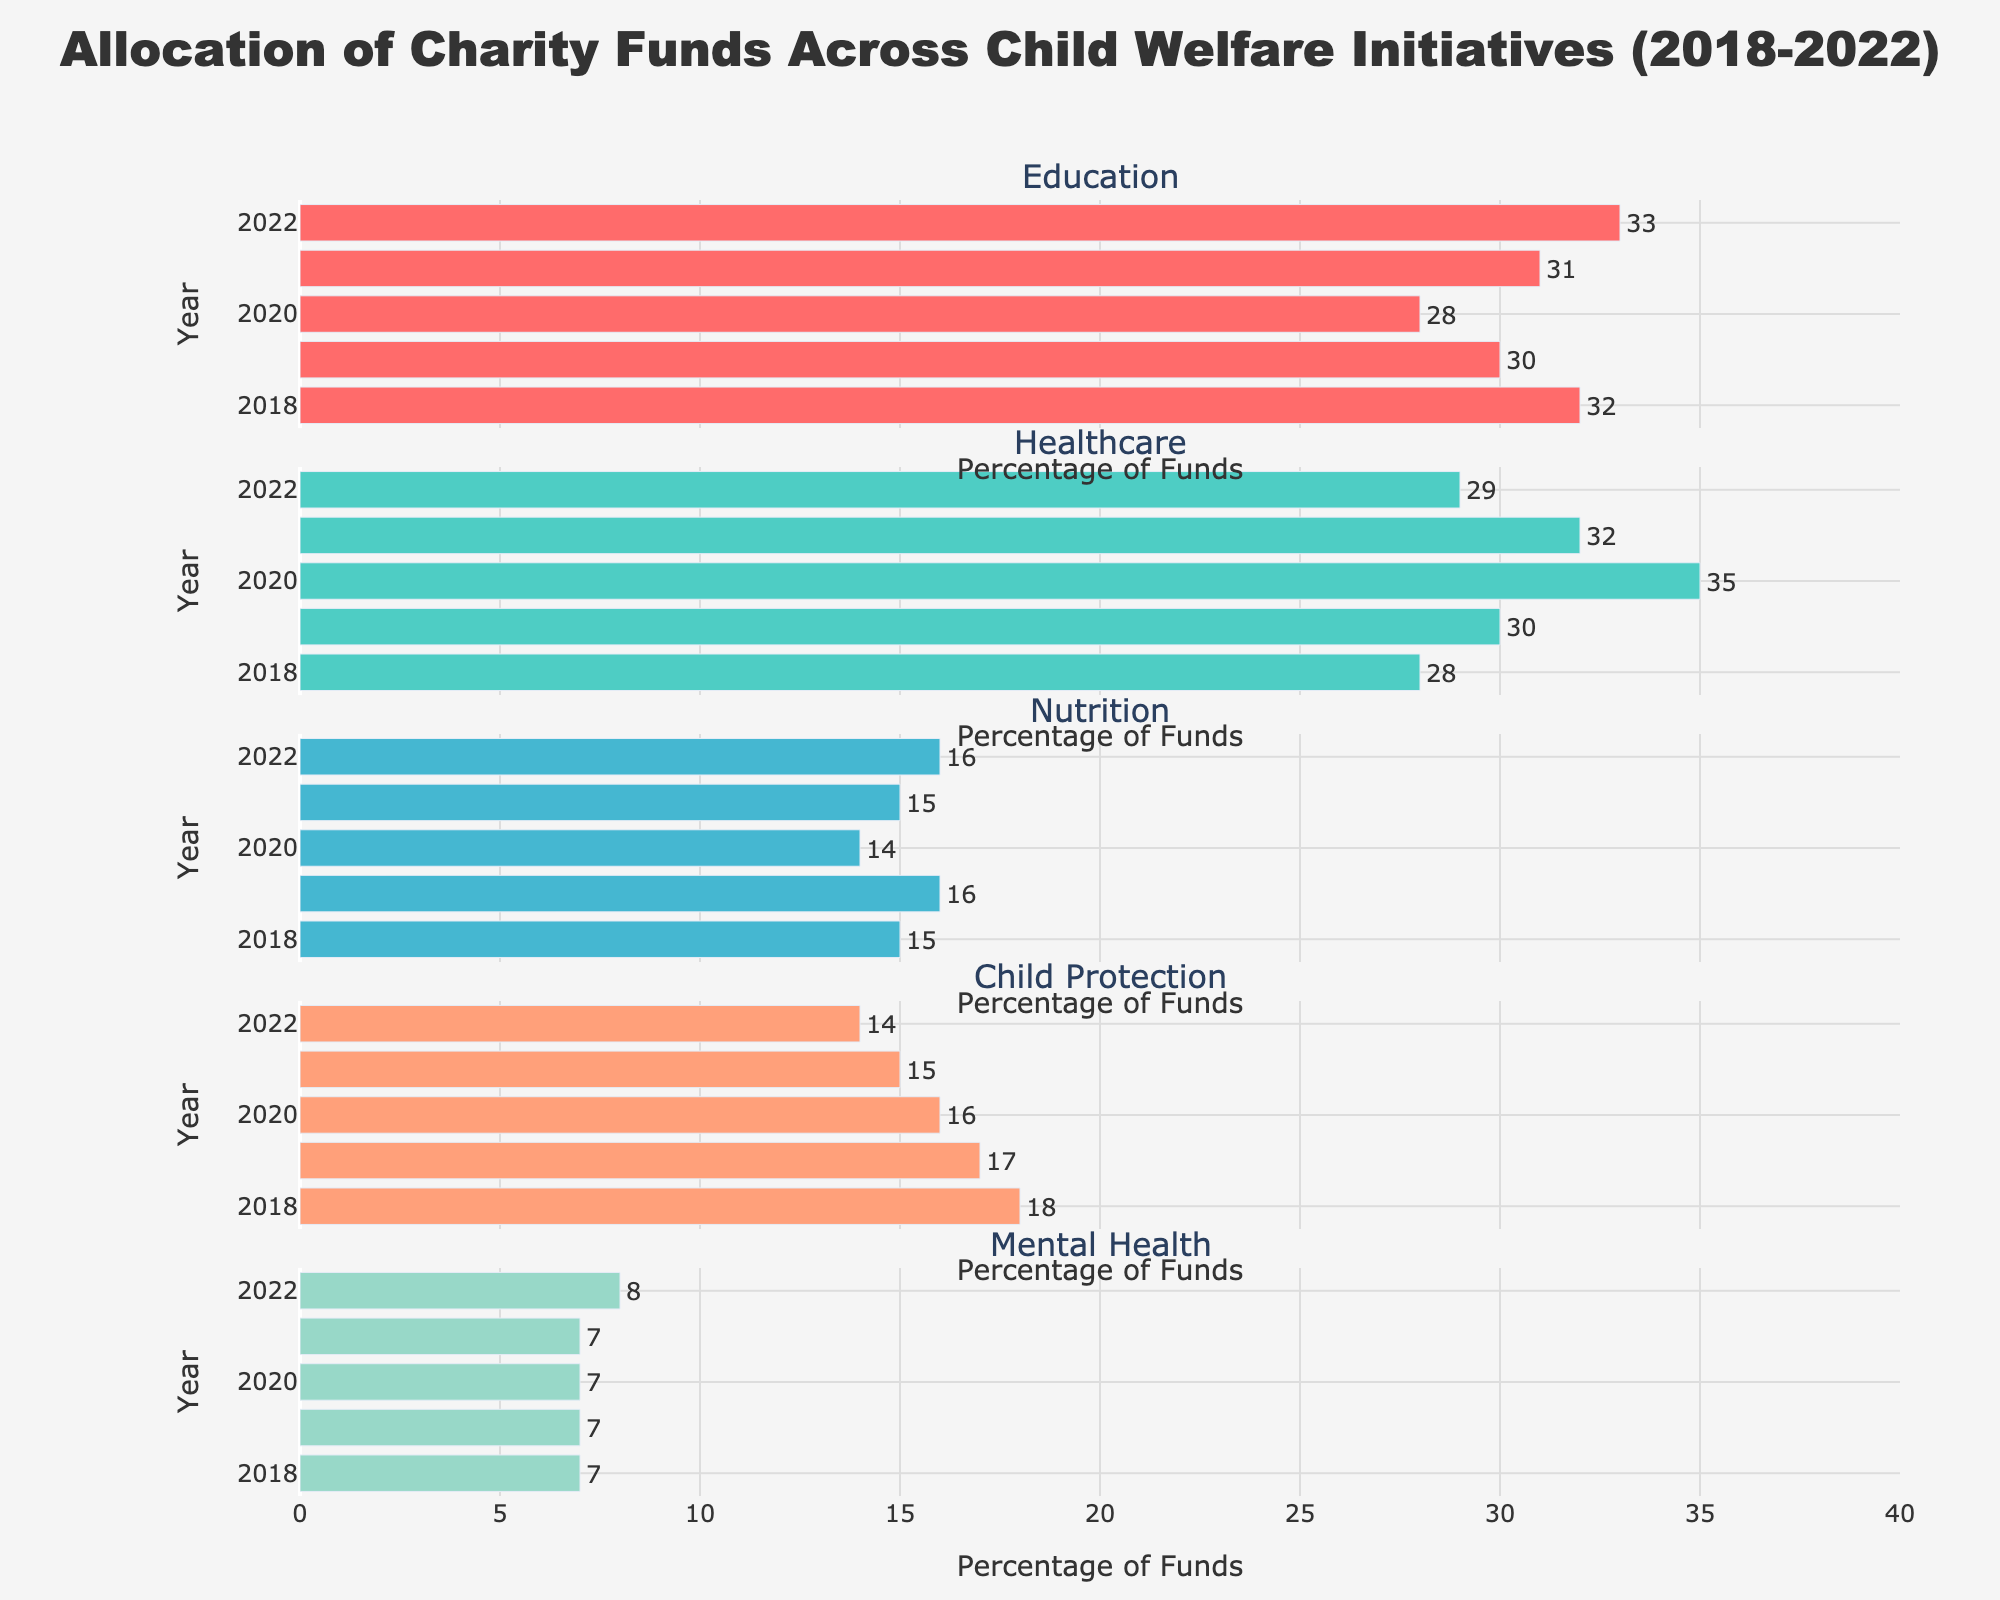How many government departments are plotted in the figure? The figure includes bars labeled for each department. Counting these labels provides the number of departments.
Answer: 10 What percentage of employees in the Defense Department have Top Secret clearance? Look at the Top Secret subplot and identify the bar corresponding to the Defense Department. The bar's height indicates the percentage.
Answer: 25% Which department has the highest percentage of Public Trust clearance? Examine the Public Trust subplot and compare the heights of the bars. Identify the tallest bar.
Answer: Agriculture What is the combined percentage of employees with Secret and Confidential clearance in the Justice Department? Find the bars corresponding to the Justice Department in the Secret and Confidential subplots, sum their heights: 32 (Secret) + 30 (Confidential) = 62
Answer: 62% Which department has the lower percentage of employees with Secret clearance, Commerce or Transportation? Compare the bars for Commerce (15%) and Transportation (12%) in the Secret subplot, noting the shorter bar.
Answer: Transportation In which department is the percentage of employees with Top Secret clearance equal to the percentage of employees with Public Trust clearance? Identify bars with equal heights in the Top Secret and Public Trust subplots. Both bars for Commerce department at 30%.
Answer: Commerce What is the difference in percentage between Top Secret and Confidential clearances in the State Department? Calculate the difference between the heights of the Top Secret (15%) and Confidential (35%) bars: 35 - 15 = 20
Answer: 20% Which department has the most uneven distribution across the four types of security clearances? Visually assess the distribution of bar heights for all departments. Identify the department with the most varied bar heights.
Answer: Transportation If you sum up the percentages of Public Trust clearance for Homeland Security and Energy departments, what is the result? Add the percentage values for Public Trust in Homeland Security (20%) and Energy (25%): 20 + 25 = 45
Answer: 45% In terms of Top Secret clearance, which department's employees have the closest percentage to the average percentage of Top Secret clearances across all departments? Calculate the average Top Secret percentage: (25+15+20+10+18+8+30+5+3+2)/10 = 13.6. Compare each department's Top Secret percentage to this average and identify the closest.
Answer: Justice 